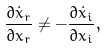<formula> <loc_0><loc_0><loc_500><loc_500>\frac { \partial \dot { x } _ { r } } { \partial x _ { r } } \neq - \frac { \partial \dot { x } _ { i } } { \partial x _ { i } } ,</formula> 